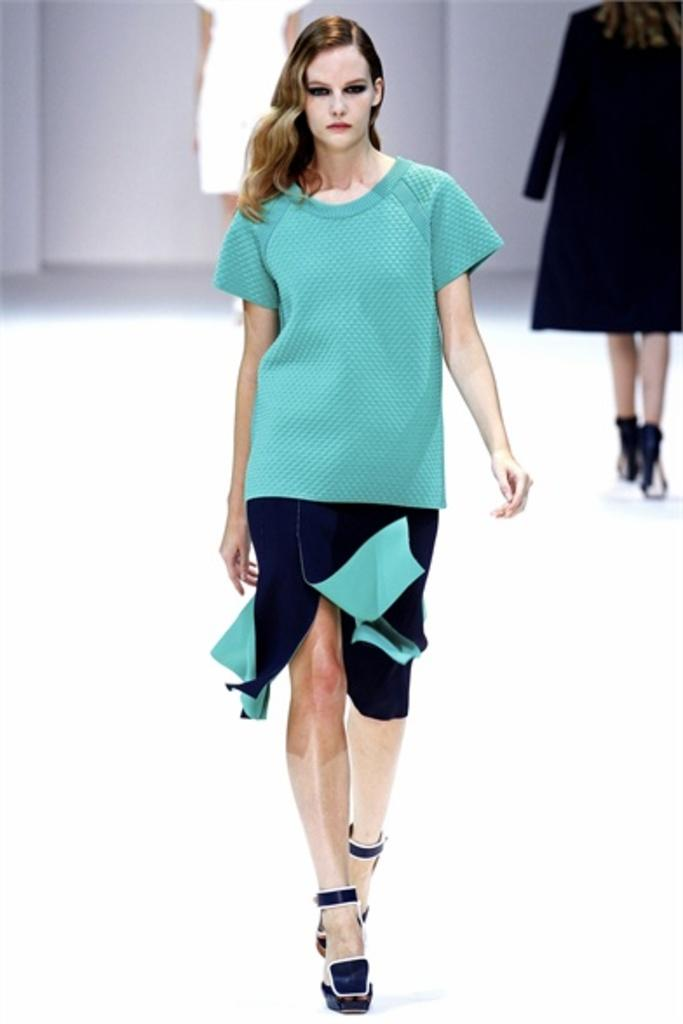What are the women in the image doing? The women in the image are walking. What surface are the women walking on? The women are walking on the floor. Can you describe the background of the image? There is a woman standing in the background of the image. What type of swing can be seen in the image? There is no swing present in the image. How does the woman in the background use her tongue in the image? The woman in the background does not use her tongue in the image; she is simply standing. 